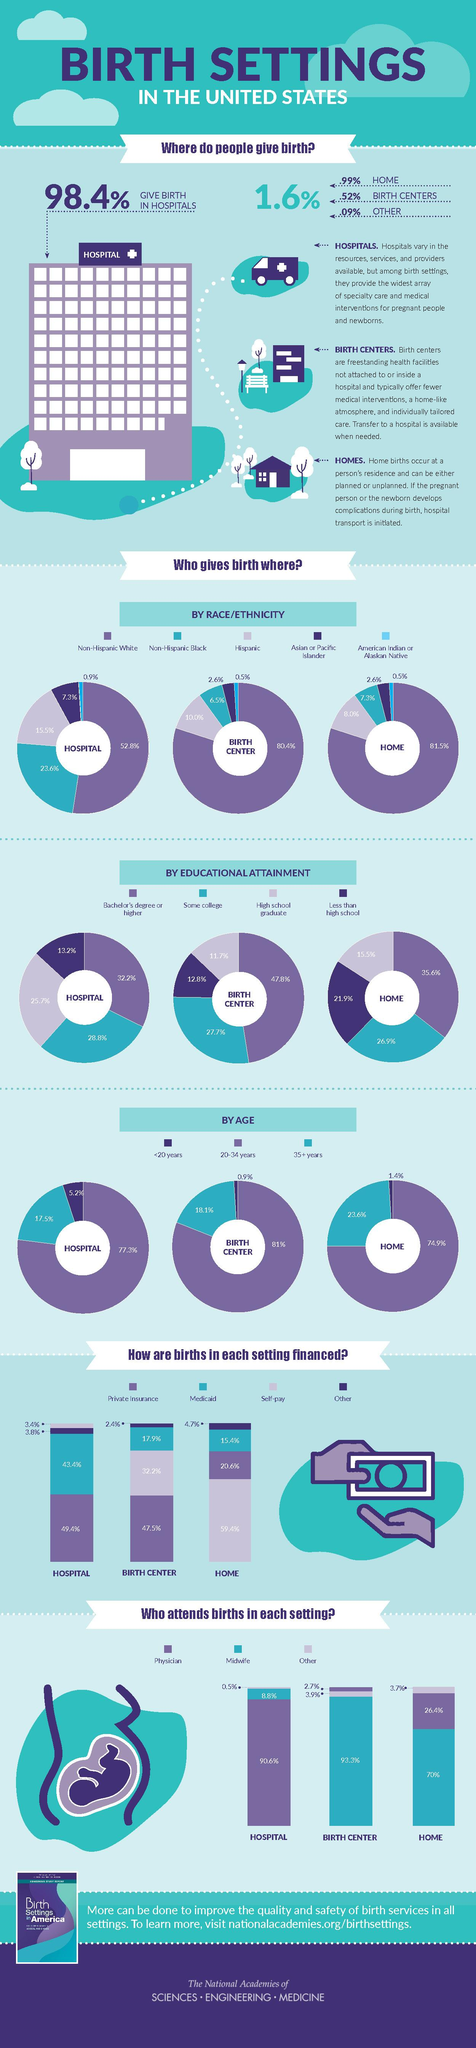List a handful of essential elements in this visual. The total percentage of American Indian and Asian births at the birth center is 3.1%. The total percentage of births financed through Medicaid at hospitals, birth centers, and homes is 76.7%. The lowest percentage value of births attended by midwives is for hospitals, with midwife attendance at births ranging from 5% to 10% in developed countries, and up to 95% in some developing countries. According to data, the percentage of women who give birth in a birth center or a hospital if they have a Bachelor's degree is 15.6%. People give birth in 4 places. 